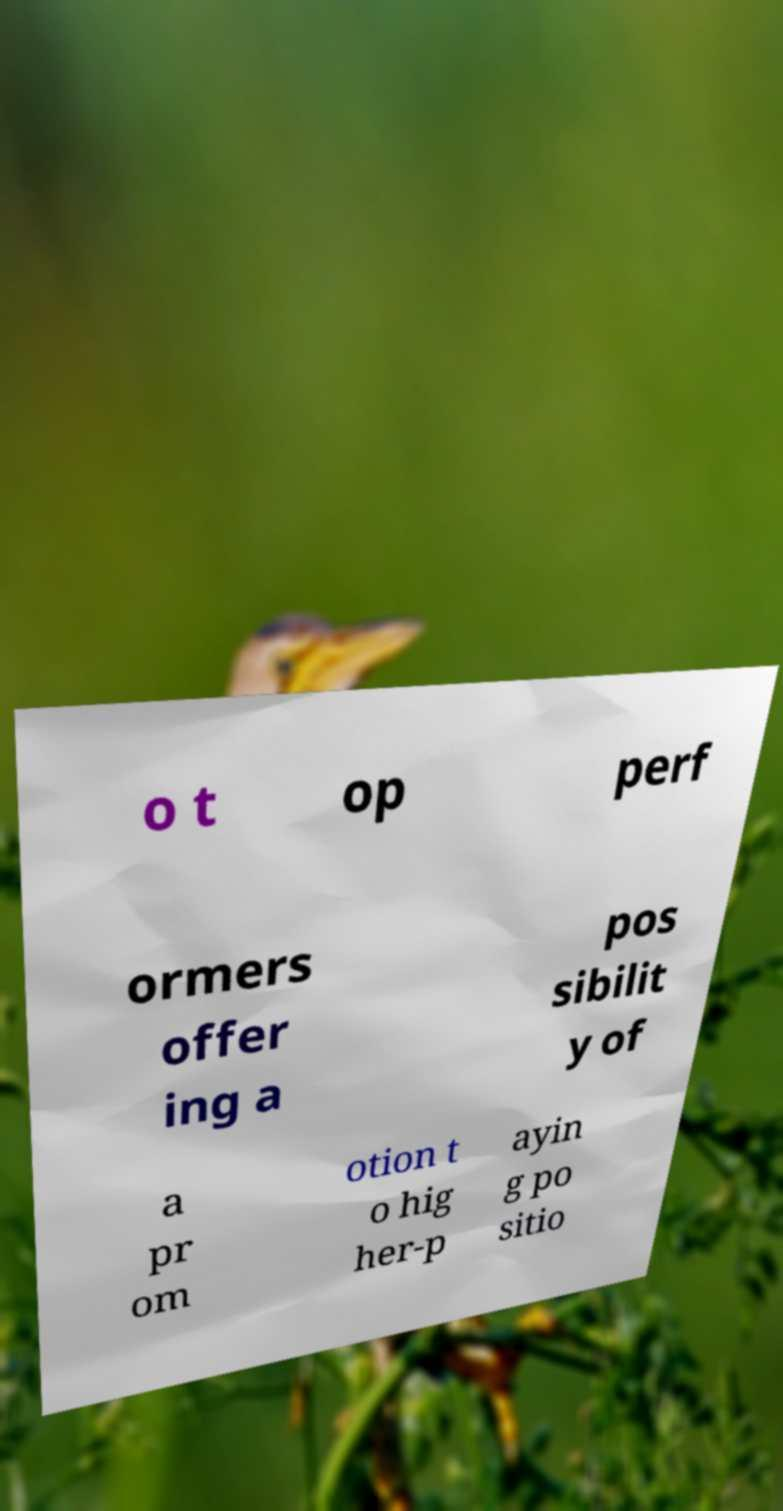For documentation purposes, I need the text within this image transcribed. Could you provide that? o t op perf ormers offer ing a pos sibilit y of a pr om otion t o hig her-p ayin g po sitio 